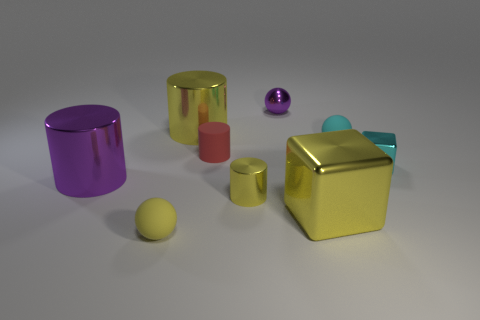How many small balls are on the right side of the purple metallic ball and in front of the cyan metal block?
Make the answer very short. 0. What number of blue things are either cubes or shiny objects?
Offer a terse response. 0. What number of metallic things are big purple objects or cyan cylinders?
Your answer should be compact. 1. Are there any big matte balls?
Provide a short and direct response. No. Do the cyan matte object and the yellow matte object have the same shape?
Make the answer very short. Yes. What number of cyan balls are in front of the yellow shiny thing that is behind the big metallic thing that is to the left of the tiny yellow matte ball?
Offer a terse response. 1. What is the material of the thing that is both right of the purple sphere and left of the small cyan rubber ball?
Provide a short and direct response. Metal. What color is the thing that is both to the right of the small metal sphere and in front of the purple cylinder?
Your answer should be compact. Yellow. Are there any other things that have the same color as the tiny shiny cube?
Your answer should be very brief. Yes. There is a big object behind the big cylinder on the left side of the small object in front of the yellow metal block; what is its shape?
Your answer should be compact. Cylinder. 